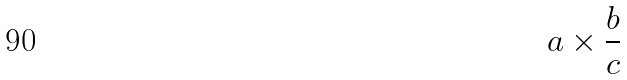Convert formula to latex. <formula><loc_0><loc_0><loc_500><loc_500>a \times \frac { b } { c }</formula> 